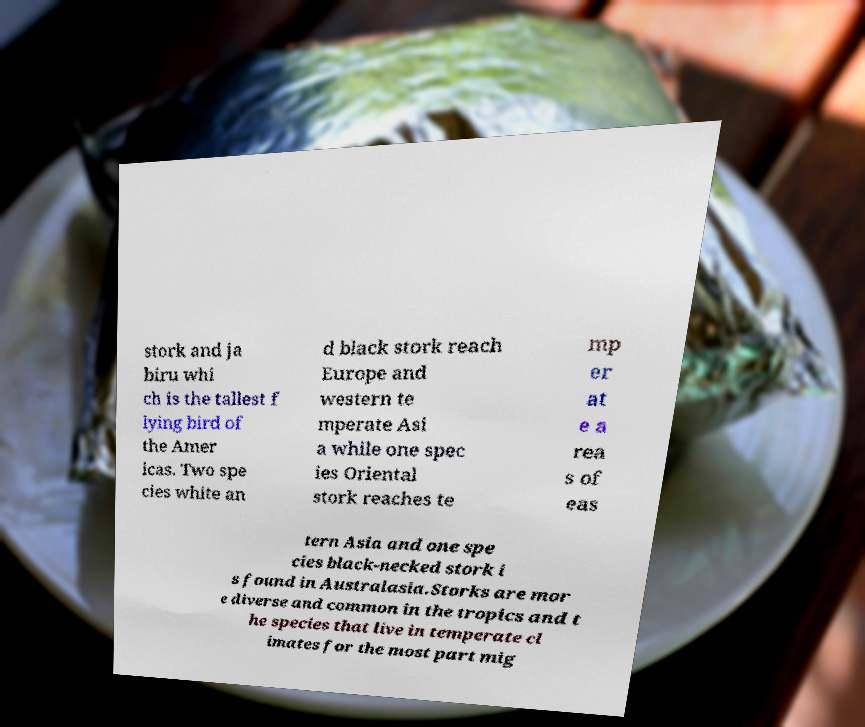For documentation purposes, I need the text within this image transcribed. Could you provide that? stork and ja biru whi ch is the tallest f lying bird of the Amer icas. Two spe cies white an d black stork reach Europe and western te mperate Asi a while one spec ies Oriental stork reaches te mp er at e a rea s of eas tern Asia and one spe cies black-necked stork i s found in Australasia.Storks are mor e diverse and common in the tropics and t he species that live in temperate cl imates for the most part mig 